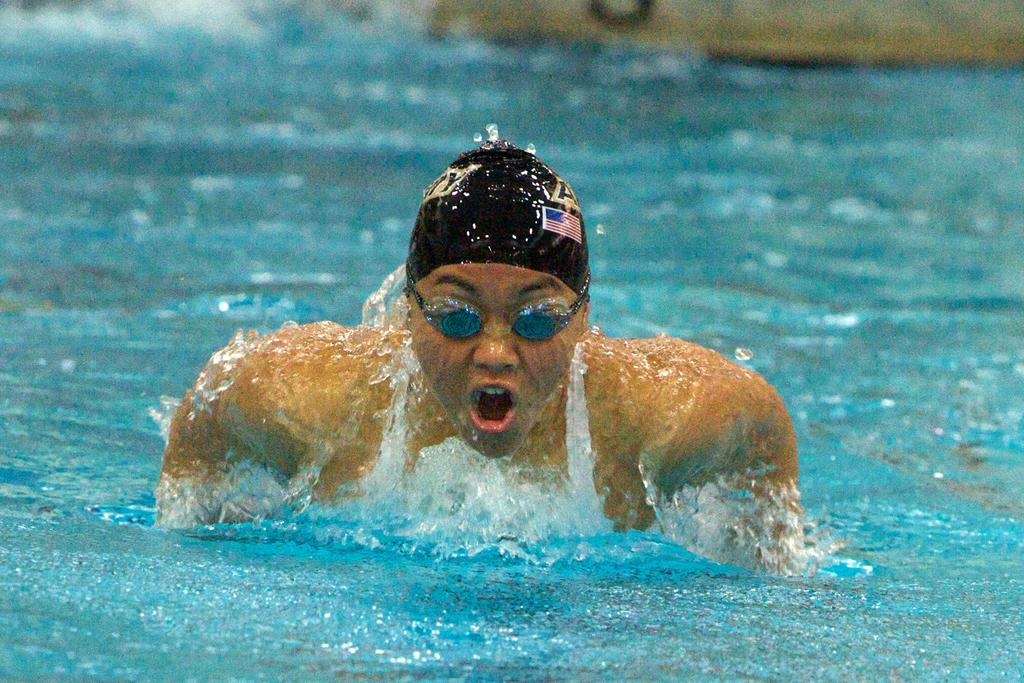Who is present in the image? There is a person in the image. What is the person wearing? The person is wearing a snorkel. What activity is the person engaged in? The person is swimming in the water. What color is the paint on the tail of the person in the image? There is no paint or tail present in the image; the person is wearing a snorkel while swimming in the water. 